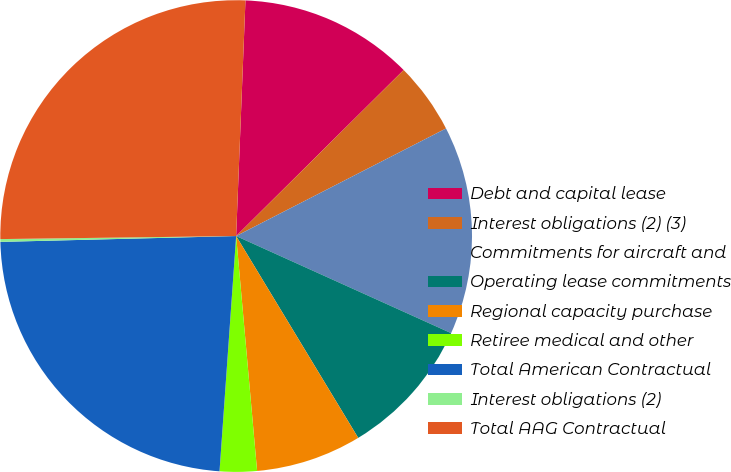Convert chart. <chart><loc_0><loc_0><loc_500><loc_500><pie_chart><fcel>Debt and capital lease<fcel>Interest obligations (2) (3)<fcel>Commitments for aircraft and<fcel>Operating lease commitments<fcel>Regional capacity purchase<fcel>Retiree medical and other<fcel>Total American Contractual<fcel>Interest obligations (2)<fcel>Total AAG Contractual<nl><fcel>11.94%<fcel>4.89%<fcel>14.29%<fcel>9.59%<fcel>7.24%<fcel>2.54%<fcel>23.48%<fcel>0.19%<fcel>25.83%<nl></chart> 